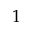<formula> <loc_0><loc_0><loc_500><loc_500>1</formula> 